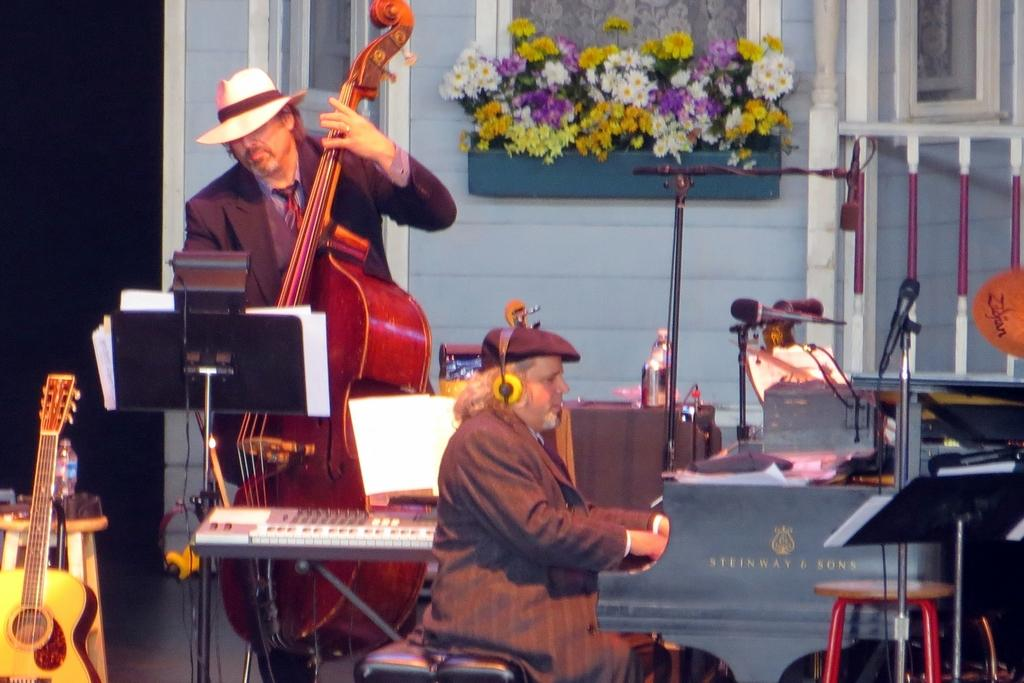What is present on the wall in the image? There is a wall in the image, but no specific details about the wall are mentioned. What can be seen besides the wall in the image? There are bouquets, two people, and musical instruments on the right side of the image. What is one of the people doing in the image? One of the people is holding a guitar. Where are the musical instruments located in the image? The musical instruments are on the right side of the image. What type of corn can be seen growing on the wall in the image? There is no corn present in the image, and the wall does not appear to have any plants growing on it. 